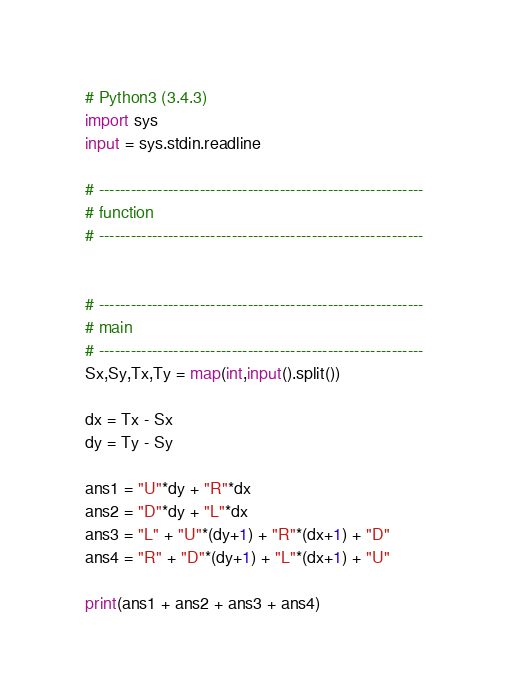Convert code to text. <code><loc_0><loc_0><loc_500><loc_500><_Python_># Python3 (3.4.3)
import sys
input = sys.stdin.readline

# -------------------------------------------------------------
# function
# -------------------------------------------------------------


# -------------------------------------------------------------
# main
# -------------------------------------------------------------
Sx,Sy,Tx,Ty = map(int,input().split())

dx = Tx - Sx
dy = Ty - Sy
 
ans1 = "U"*dy + "R"*dx
ans2 = "D"*dy + "L"*dx
ans3 = "L" + "U"*(dy+1) + "R"*(dx+1) + "D"
ans4 = "R" + "D"*(dy+1) + "L"*(dx+1) + "U"
 
print(ans1 + ans2 + ans3 + ans4)</code> 